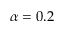Convert formula to latex. <formula><loc_0><loc_0><loc_500><loc_500>\alpha = 0 . 2</formula> 